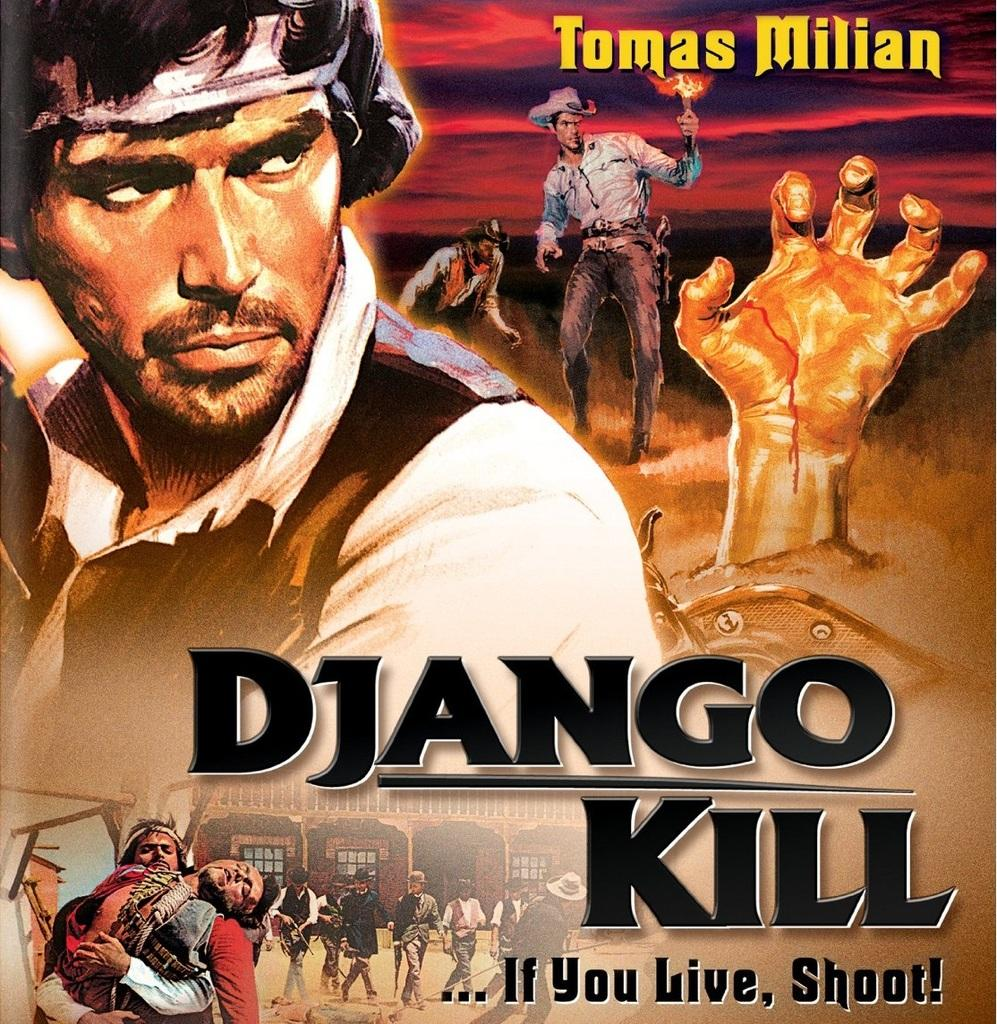What is present in the image that features images and text? There is a poster in the image that contains images of people and text. Can you describe the images on the poster? The poster contains images of people and an image of a hand. What is the purpose of the hand image on the poster? The purpose of the hand image on the poster is not clear from the given facts, but it is present alongside the images of people. How many pigs are visible behind the curtain in the image? There are no pigs or curtains present in the image; it features a poster with images of people and text. 